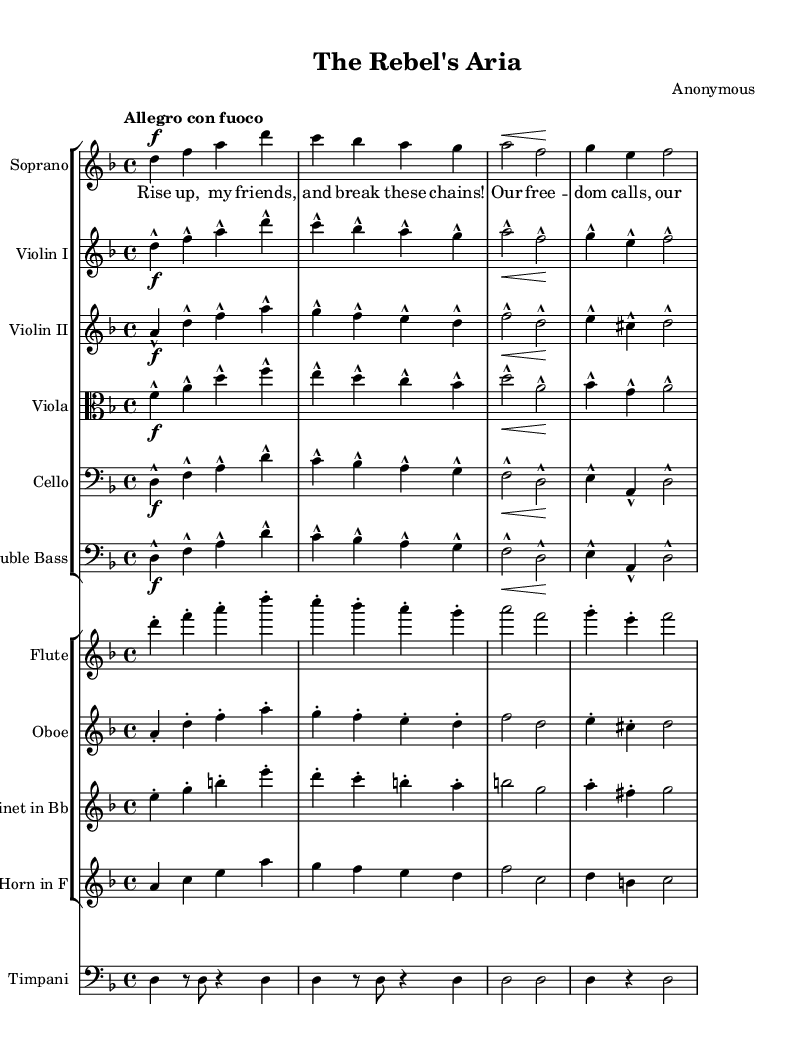What is the key signature of this music? The key signature is D minor, indicated by one flat (B flat) which affects all B notes in the piece.
Answer: D minor What is the time signature of this music? The time signature is 4/4, which indicates there are four beats in each measure and the quarter note gets one beat.
Answer: 4/4 What is the tempo marking of this music? The tempo marking is "Allegro con fuoco," suggesting a fast tempo with fire or passion.
Answer: Allegro con fuoco What instrument plays the melody in this score? The soprano voice plays the melody in this score, as evidenced by the lyrics and notation in the soprano staff.
Answer: Soprano Which instruments are playing in unison with the soprano part? The strings, specifically Violin I, Violin II, Viola, Cello, and Double Bass, are playing in unison with the soprano. The same notes appear in their respective parts throughout the first few measures.
Answer: Strings What is the highest note played in the piece? The highest note in this score is 'a', which occurs multiple times in the soprano and violin parts.
Answer: A What musical technique is indicated by the markings in the flute part? The flute part indicates staccato markings, instructing the player to perform the notes in a detached manner, creating a light and crisp sound.
Answer: Staccato 